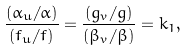Convert formula to latex. <formula><loc_0><loc_0><loc_500><loc_500>\frac { ( \alpha _ { u } / \alpha ) } { ( f _ { u } / f ) } = \frac { ( g _ { v } / g ) } { ( \beta _ { v } / \beta ) } = k _ { 1 } ,</formula> 